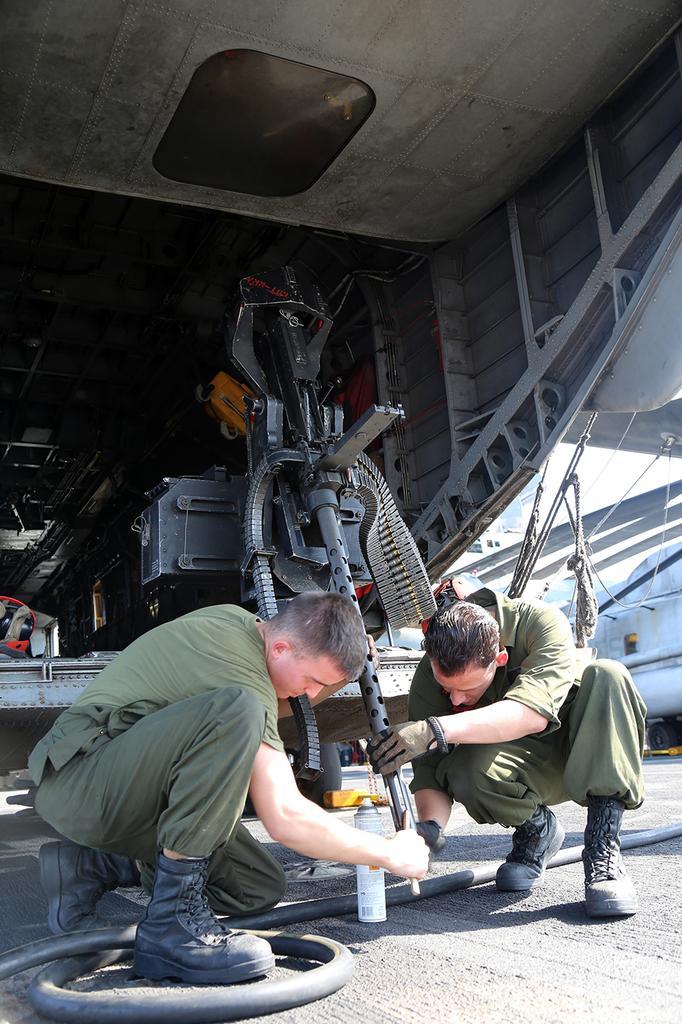How would you summarize this image in a sentence or two? In the image there are two men sitting on the road holding a machine which is on a table and above there is ceiling. 